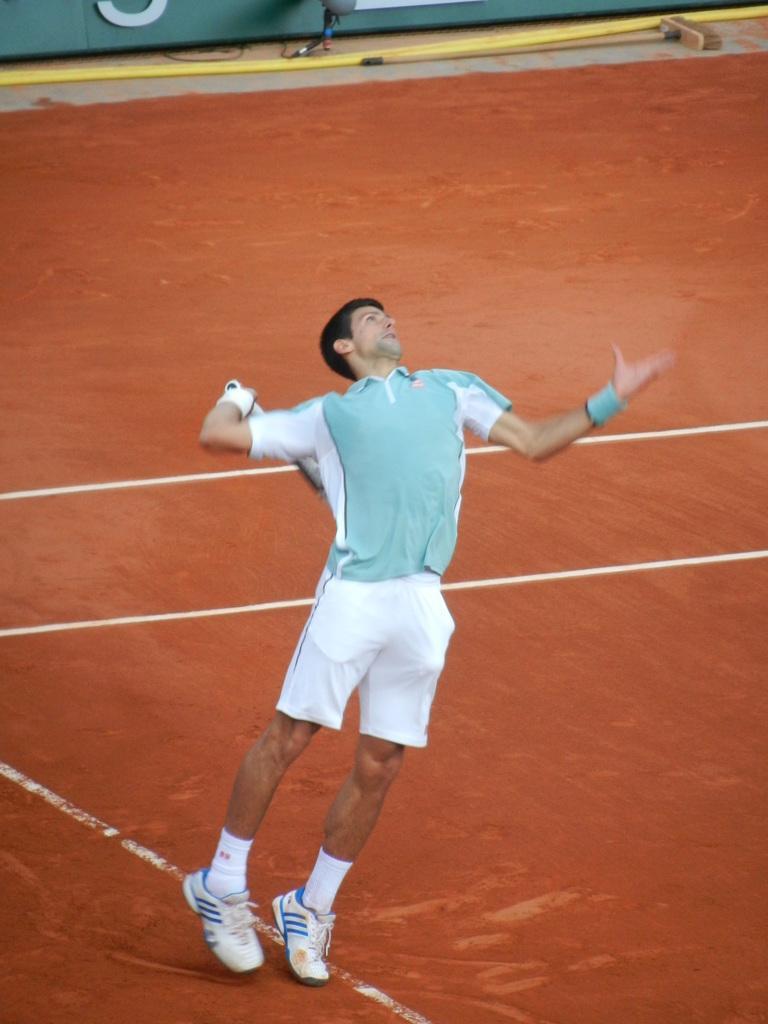How would you summarize this image in a sentence or two? The image is inside a playground. In the image there is a man holding a racket and playing with it, at bottom there is a land which is in red color. 